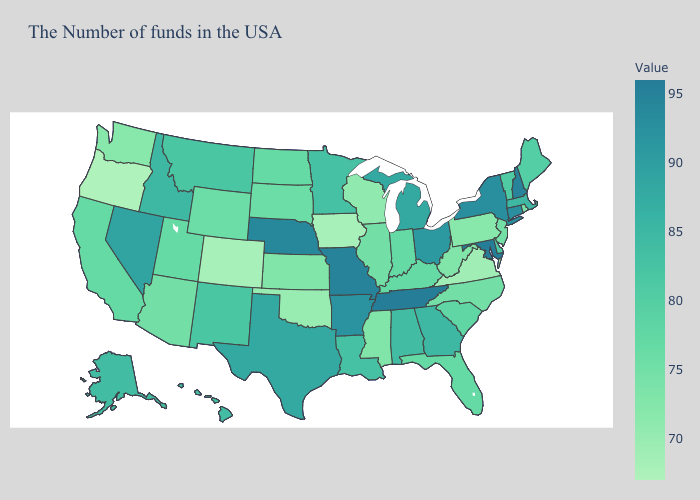Is the legend a continuous bar?
Give a very brief answer. Yes. Which states have the lowest value in the Northeast?
Be succinct. Pennsylvania. Among the states that border Florida , does Georgia have the lowest value?
Concise answer only. No. Among the states that border Kansas , does Colorado have the lowest value?
Short answer required. Yes. Among the states that border Colorado , which have the lowest value?
Concise answer only. Oklahoma. Does North Carolina have a lower value than Pennsylvania?
Write a very short answer. No. Which states have the highest value in the USA?
Be succinct. Maryland, Tennessee. 